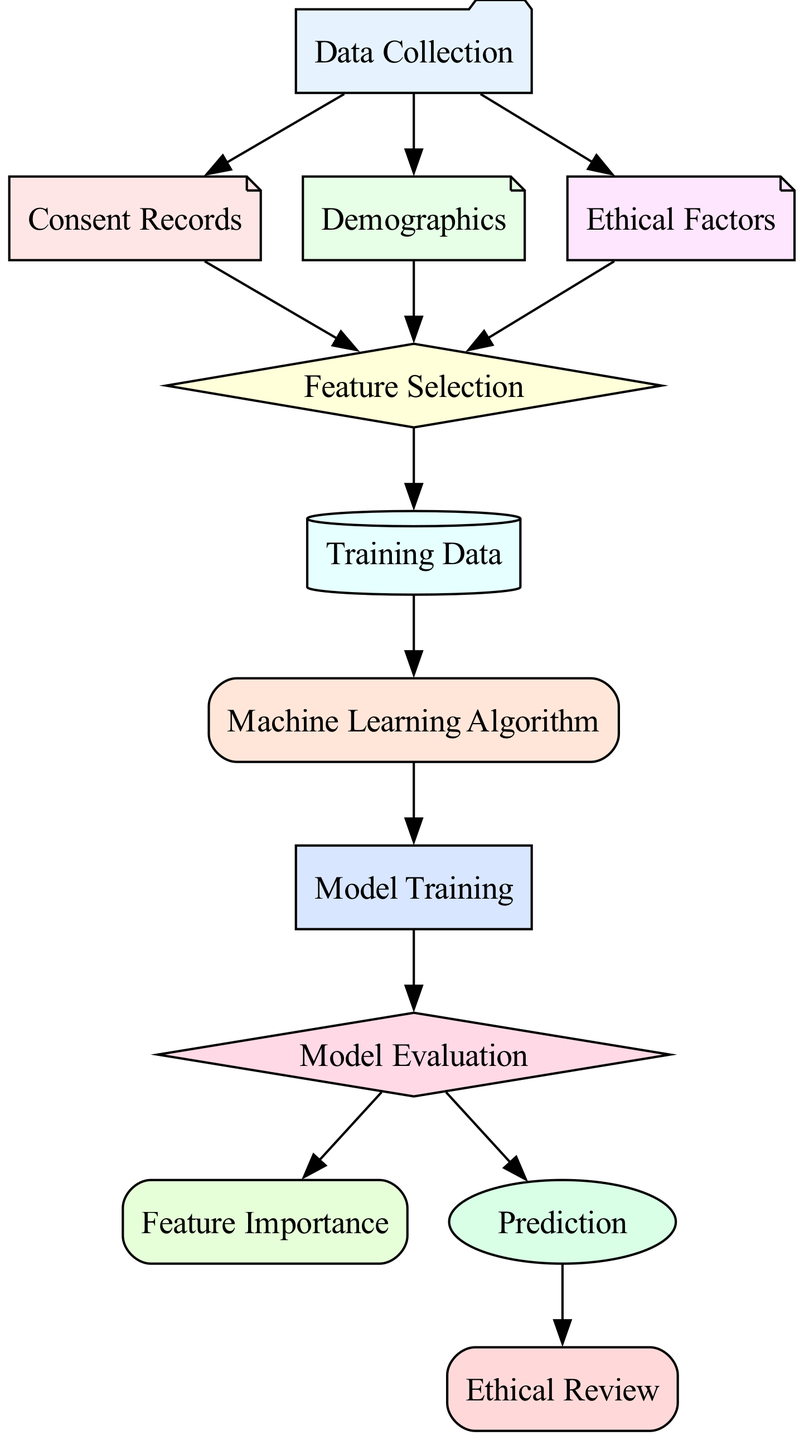What is the first node in the diagram? The diagram lists "Data Collection" as the first node in the flow of the predictive model.
Answer: Data Collection How many nodes are in the diagram? Upon inspecting the diagram, there are 11 nodes representing different components of the predictive model.
Answer: 11 What type of algorithm is represented in the diagram? The diagram mentions that the algorithm could be Random Forest, SVM, or Neural Network, indicating different types of machine learning algorithms utilized.
Answer: Random Forest, SVM, Neural Network Which node connects "Demographics" to "Feature Selection"? The flow indicates a direct connection from the "Demographics" node to the "Feature Selection" node, illustrating that demographic information contributes to feature selection.
Answer: Feature Selection What comes after "Model Training" in the diagram? Following "Model Training," the next node in the sequence is "Evaluation," which is responsible for assessing the model's performance.
Answer: Evaluation Which nodes contribute data to "Feature Selection"? The nodes that feed into "Feature Selection" include "Consent Records," "Demographics," and "Ethical Factors," indicating that all three aspects influence the selection of relevant features.
Answer: Consent Records, Demographics, Ethical Factors What is the purpose of the "Ethical Review" node? The "Ethical Review" node ensures that the model adheres to established ethical standards in the predictive modeling process, particularly focusing on participant compliance with informed consent.
Answer: Ensure ethical standards How is "Feature Importance" assessed according to the diagram? "Feature Importance" is evaluated after "Model Evaluation," suggesting that the assessment of model performance precedes the ranking of features by their predictive power.
Answer: After Model Evaluation What role does "Training Data" serve in the model? "Training Data" acts as the preprocessed and selected features data that the machine learning algorithm utilizes to train the model effectively.
Answer: Preprocessed and selected features data 